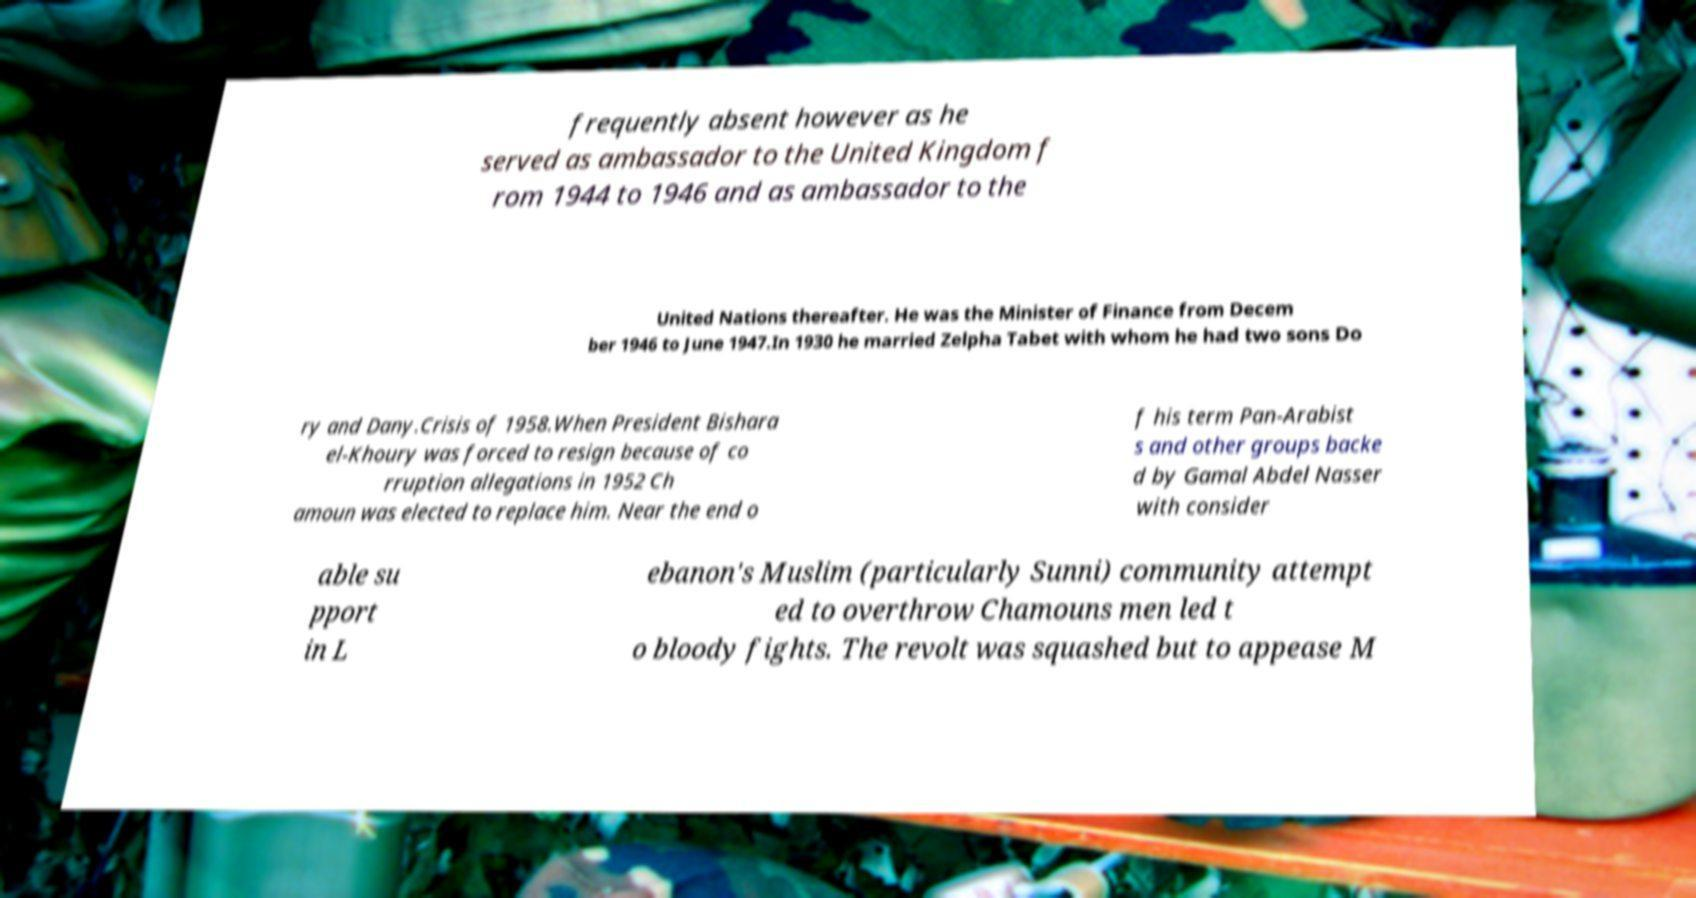Please read and relay the text visible in this image. What does it say? frequently absent however as he served as ambassador to the United Kingdom f rom 1944 to 1946 and as ambassador to the United Nations thereafter. He was the Minister of Finance from Decem ber 1946 to June 1947.In 1930 he married Zelpha Tabet with whom he had two sons Do ry and Dany.Crisis of 1958.When President Bishara el-Khoury was forced to resign because of co rruption allegations in 1952 Ch amoun was elected to replace him. Near the end o f his term Pan-Arabist s and other groups backe d by Gamal Abdel Nasser with consider able su pport in L ebanon's Muslim (particularly Sunni) community attempt ed to overthrow Chamouns men led t o bloody fights. The revolt was squashed but to appease M 